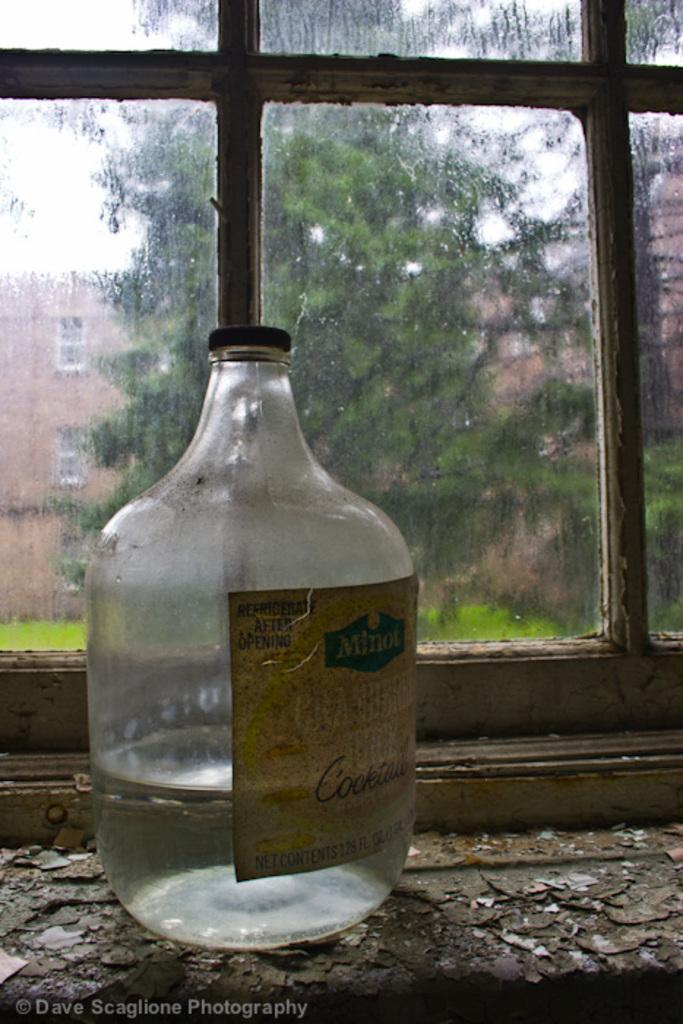<image>
Give a short and clear explanation of the subsequent image. A bottle of Minot Cocktail sits on a chipped wooden windowsill. 